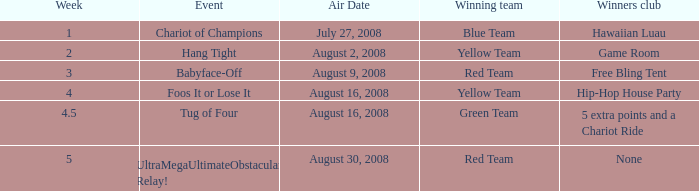Which winners club hosts a hang tight event? Game Room. 